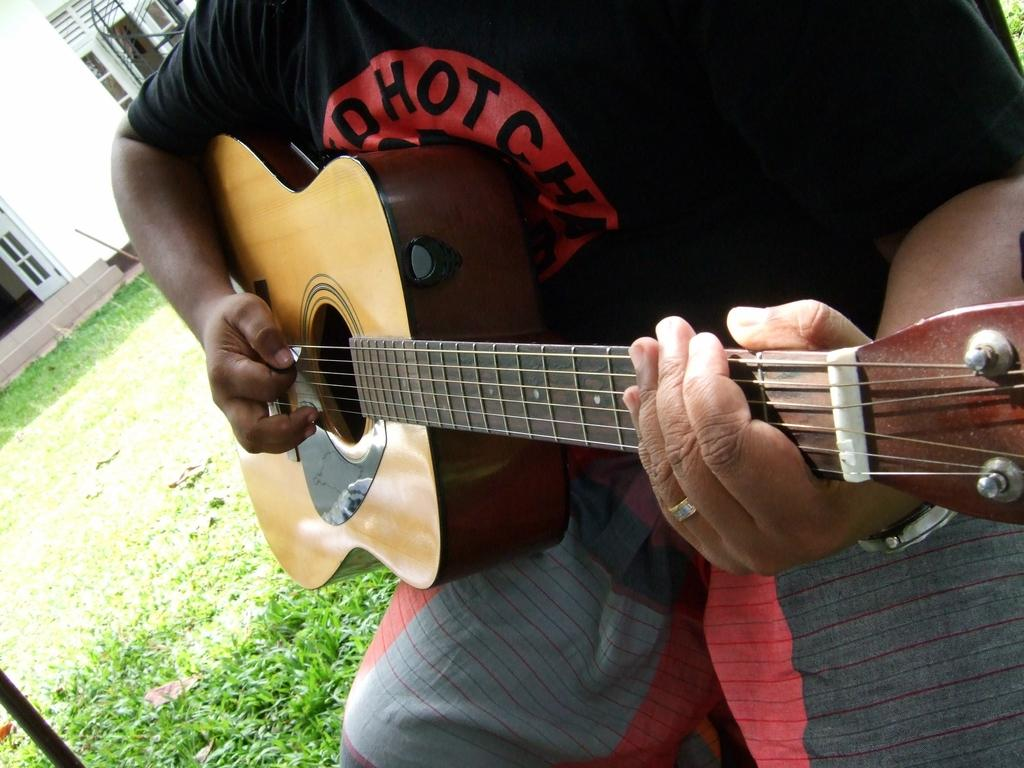What is the main subject of the image? There is a person in the image. What is the person holding in the image? The person is holding a guitar. What type of environment is visible in the image? There is grass visible in the image, suggesting an outdoor setting. What type of distribution system is being used to deliver the guitar in the image? There is no distribution system present in the image; the person is simply holding the guitar. 